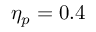<formula> <loc_0><loc_0><loc_500><loc_500>\eta _ { p } = 0 . 4</formula> 